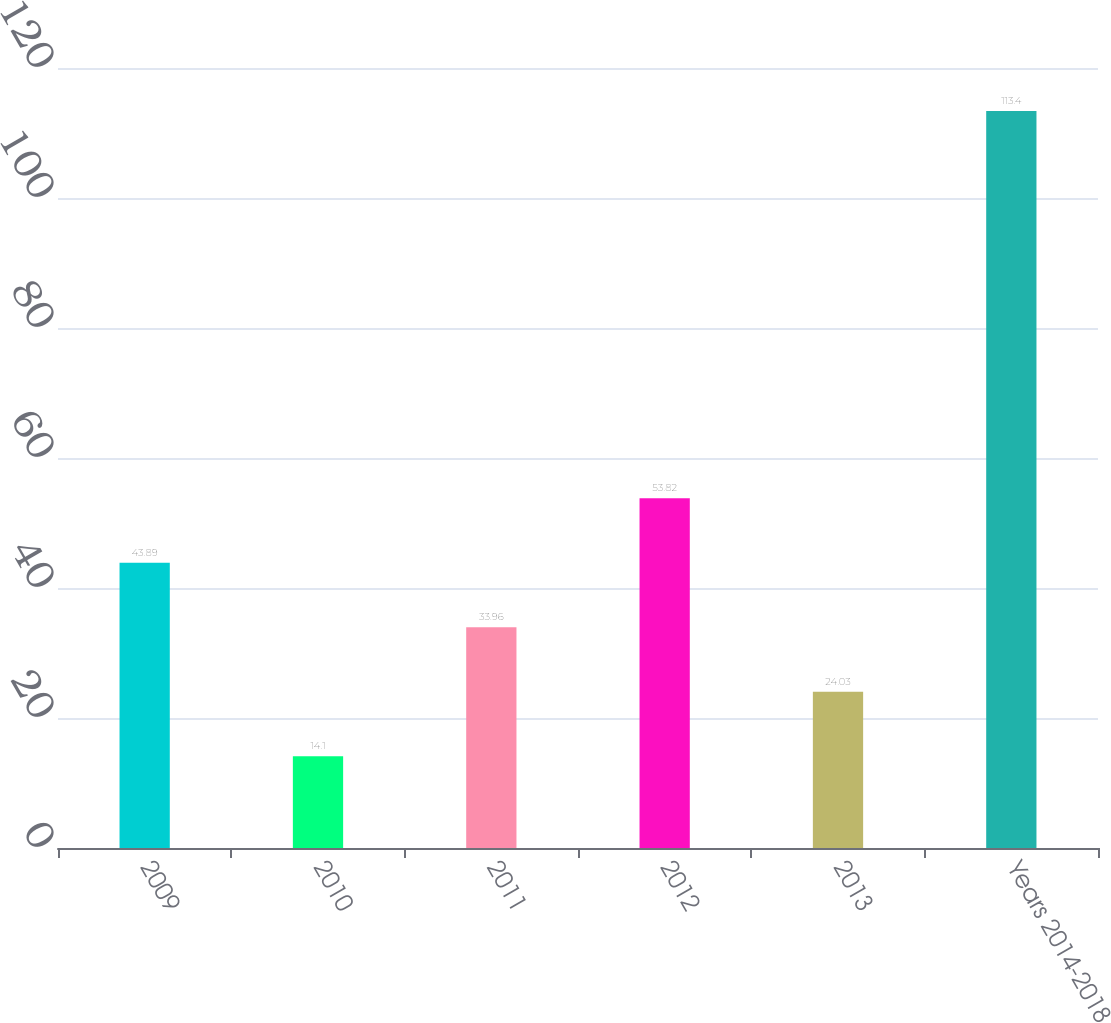<chart> <loc_0><loc_0><loc_500><loc_500><bar_chart><fcel>2009<fcel>2010<fcel>2011<fcel>2012<fcel>2013<fcel>Years 2014-2018<nl><fcel>43.89<fcel>14.1<fcel>33.96<fcel>53.82<fcel>24.03<fcel>113.4<nl></chart> 